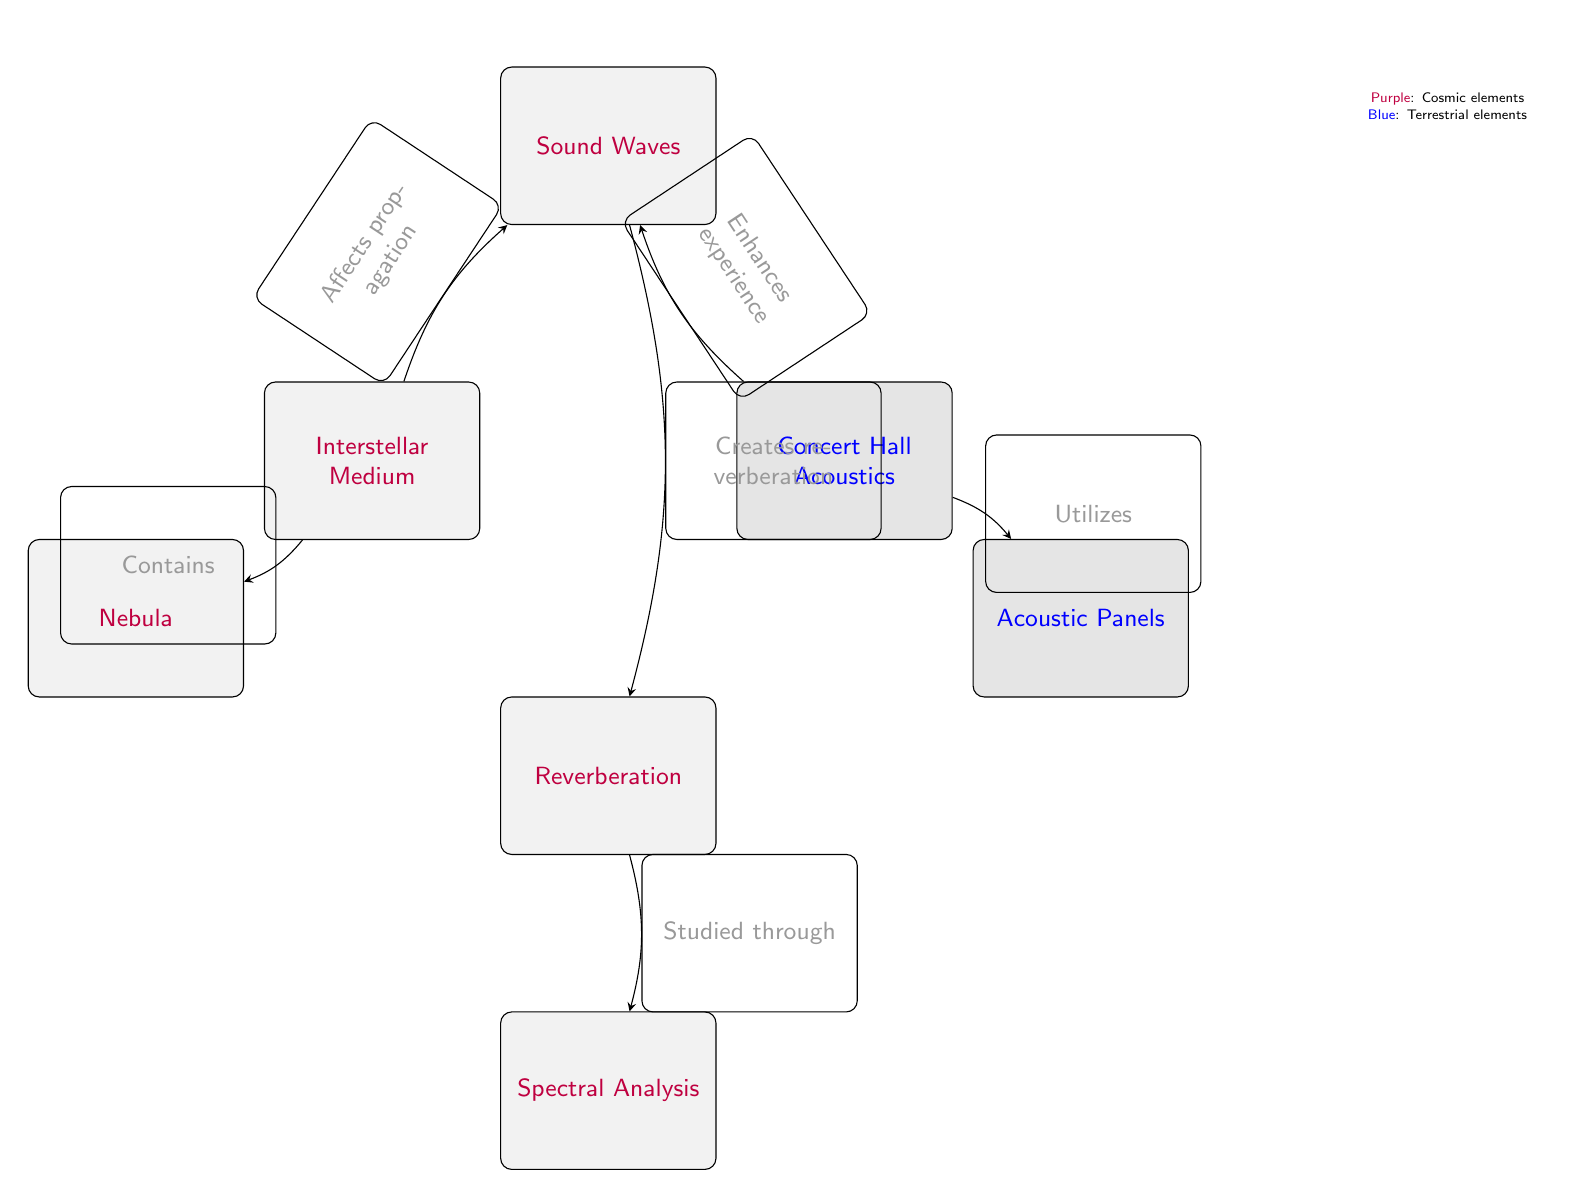what are the two main categories represented in the diagram? The diagram features two distinct categories: cosmic elements represented by purple nodes and terrestrial elements represented by blue nodes. These categories are clearly labeled through the legend in the diagram.
Answer: cosmic and terrestrial how many nodes are depicted in the diagram? Upon examining the diagram, we count the nodes: Interstellar Medium, Concert Hall Acoustics, Sound Waves, Reverberation, Nebula, Acoustic Panels, and Spectral Analysis, totaling seven nodes.
Answer: 7 which node directly relates to both the Interstellar Medium and Sound Waves? The node 'Sound Waves' connects directly to both 'Interstellar Medium' and 'Concert Hall Acoustics'. Specifically, the 'Interstellar Medium' affects the propagation of Sound Waves, as shown by the edge connecting these two nodes.
Answer: Sound Waves which element enhances the listening experience in the context of the diagram? The 'Concert Hall Acoustics' node enhances the experience through its relationship with the 'Sound Waves' node, suggesting that this setting contributes positively to the auditory experience in concert environments.
Answer: Concert Hall Acoustics what is the direction of the flow from Reverberation to Spectral Analysis? The flow direction indicates that Reverberation is studied through Spectral Analysis, represented by the arrow connecting the two nodes. This shows a one-way relationship where Reverberation leads to the study via Spectral Analysis.
Answer: Studied through how does the Interstellar Medium affect Sound Waves according to the diagram? The diagram illustrates that the Interstellar Medium affects the propagation of Sound Waves, indicating that the nature of the medium can influence how sound travels in space.
Answer: Affects propagation what do Acoustic Panels do in relation to Sound Waves? Acoustic Panels are used in conjunction with Sound Waves in the Concert Hall Acoustics, as indicated by the directed edge that implies utilization; they help manage sound quality within a space.
Answer: Utilizes what is contained within the Interstellar Medium as per the visual representation? The diagram shows that the Interstellar Medium contains Nebula, as indicated by the directional edge connecting these two nodes, illustrating a relation of inclusion.
Answer: Nebula 